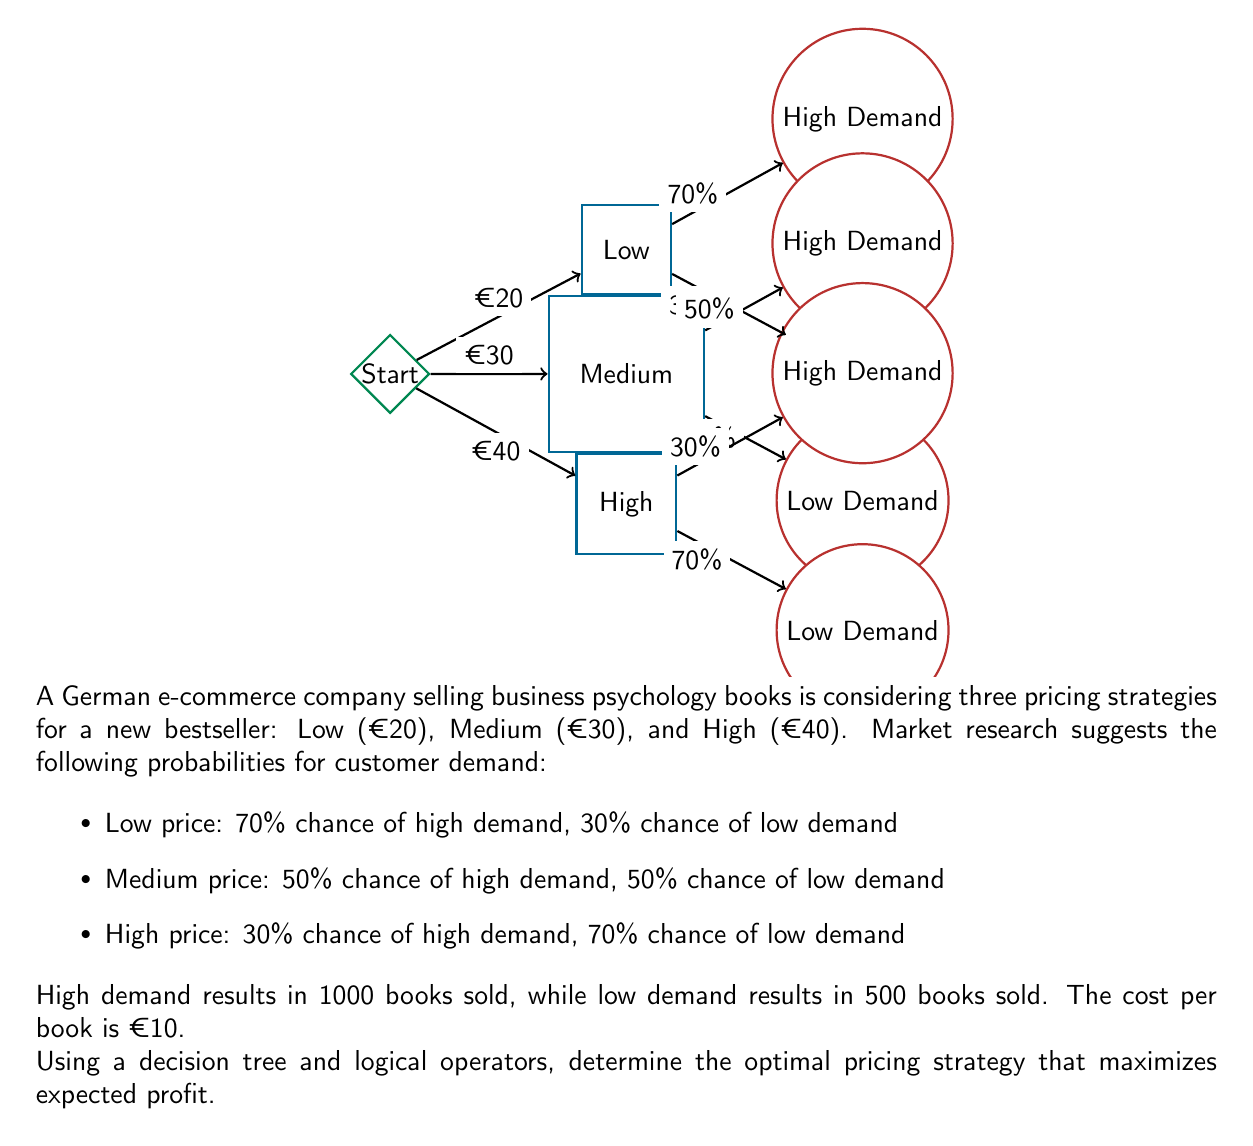Can you answer this question? Let's approach this step-by-step using decision tree analysis and logical operators:

1) First, calculate the profit for each scenario:

   Profit = (Price - Cost) * Units Sold

2) Low price (€20):
   - High demand: $(20 - 10) * 1000 = €10,000$
   - Low demand: $(20 - 10) * 500 = €5,000$
   Expected profit: $0.7 * 10000 + 0.3 * 5000 = €8,500$

3) Medium price (€30):
   - High demand: $(30 - 10) * 1000 = €20,000$
   - Low demand: $(30 - 10) * 500 = €10,000$
   Expected profit: $0.5 * 20000 + 0.5 * 10000 = €15,000$

4) High price (€40):
   - High demand: $(40 - 10) * 1000 = €30,000$
   - Low demand: $(40 - 10) * 500 = €15,000$
   Expected profit: $0.3 * 30000 + 0.7 * 15000 = €19,500$

5) Now, we use logical operators to determine the optimal strategy:

   Let $P_L$, $P_M$, and $P_H$ represent the expected profits for Low, Medium, and High pricing strategies respectively.

   $P_L = 8500$
   $P_M = 15000$
   $P_H = 19500$

   The optimal strategy is the one with the maximum expected profit:

   $\text{Optimal} = \max(P_L, P_M, P_H)$

   $(P_H > P_M) \land (P_H > P_L) \implies \text{High price is optimal}$

Therefore, the optimal pricing strategy is the High price (€40), which yields the maximum expected profit of €19,500.
Answer: High price (€40) 